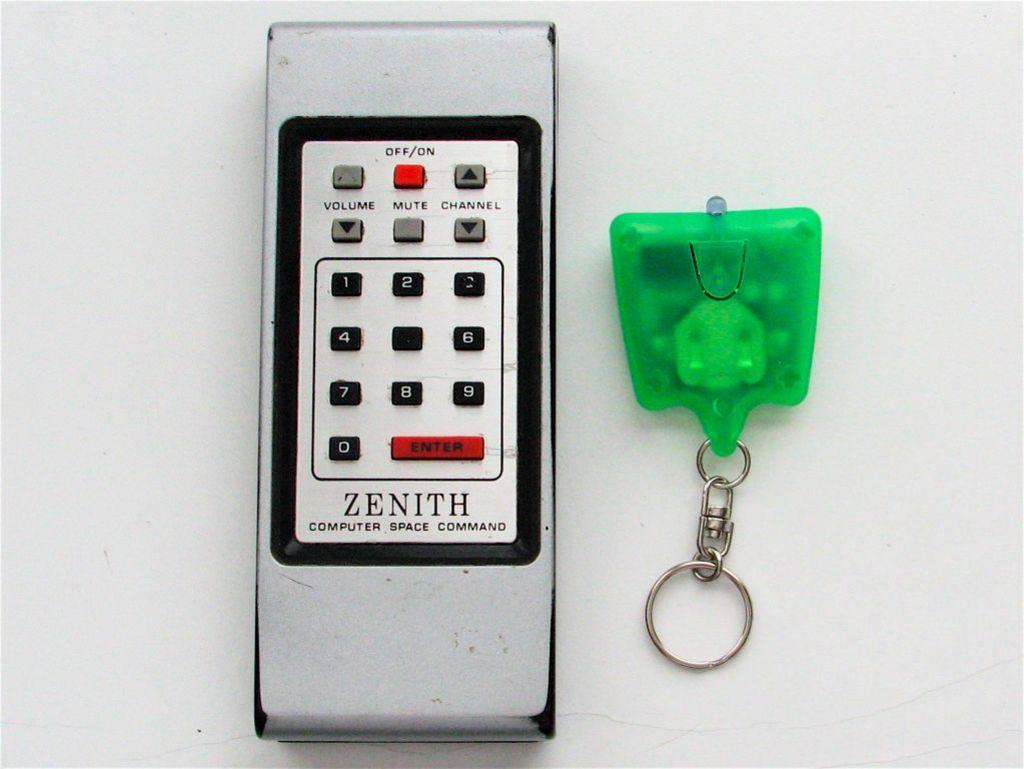<image>
Offer a succinct explanation of the picture presented. the word zenith that is on a phone 